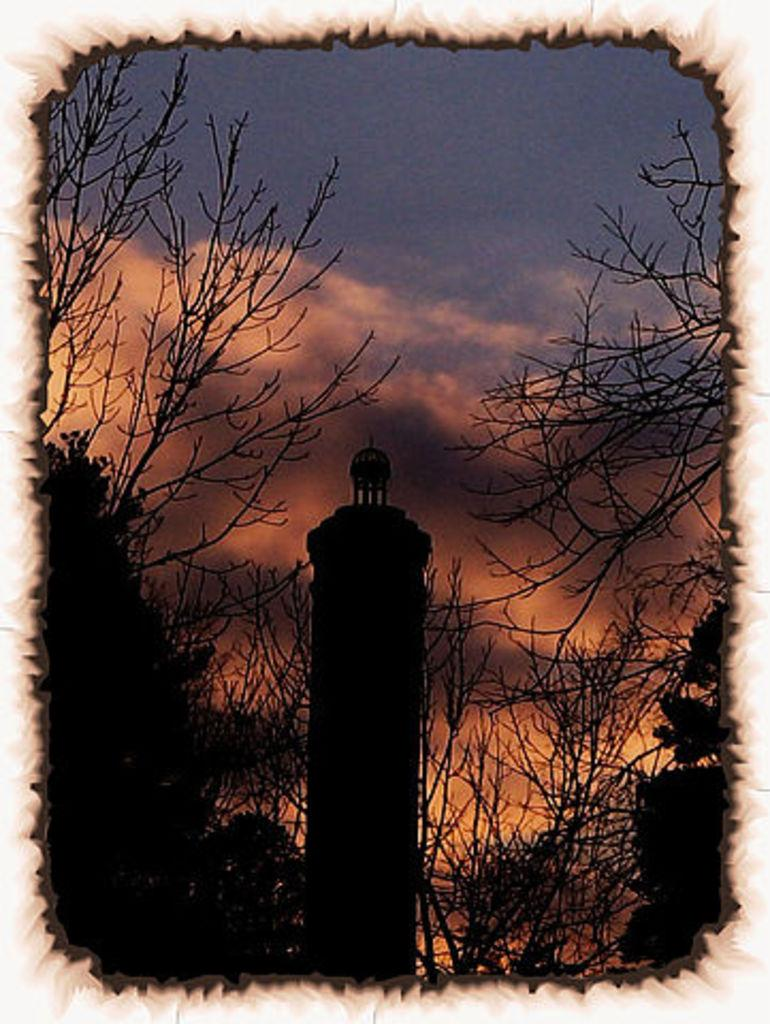What editing technique has been applied to the image? The image is edited. What is the main subject in the center of the image? There is a tower in the center of the image. What type of vegetation can be seen in the image? There are trees in the image. What can be seen in the background of the image? There are clouds and the sky visible in the background of the image. What type of heart-shaped collar can be seen on the tower in the image? There is no heart-shaped collar present on the tower in the image. How many pins are holding the clouds in place in the image? There are no pins holding the clouds in place in the image; they are a natural part of the sky. 